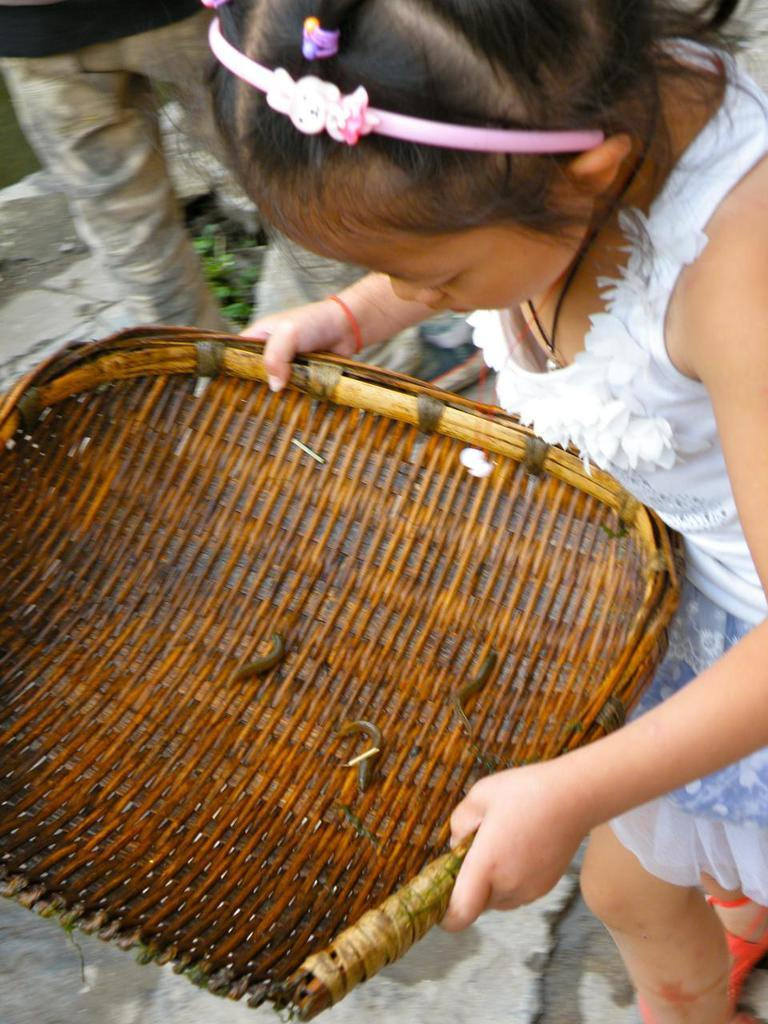How many people are in the image? There are two persons in the image. What are the positions of the persons in the image? Both persons are standing on the ground. Is one of the persons holding anything? Yes, one of the persons is holding an object. What is the distance between the persons and the moon in the image? There is no moon visible in the image, so it is not possible to determine the distance between the persons and the moon. 